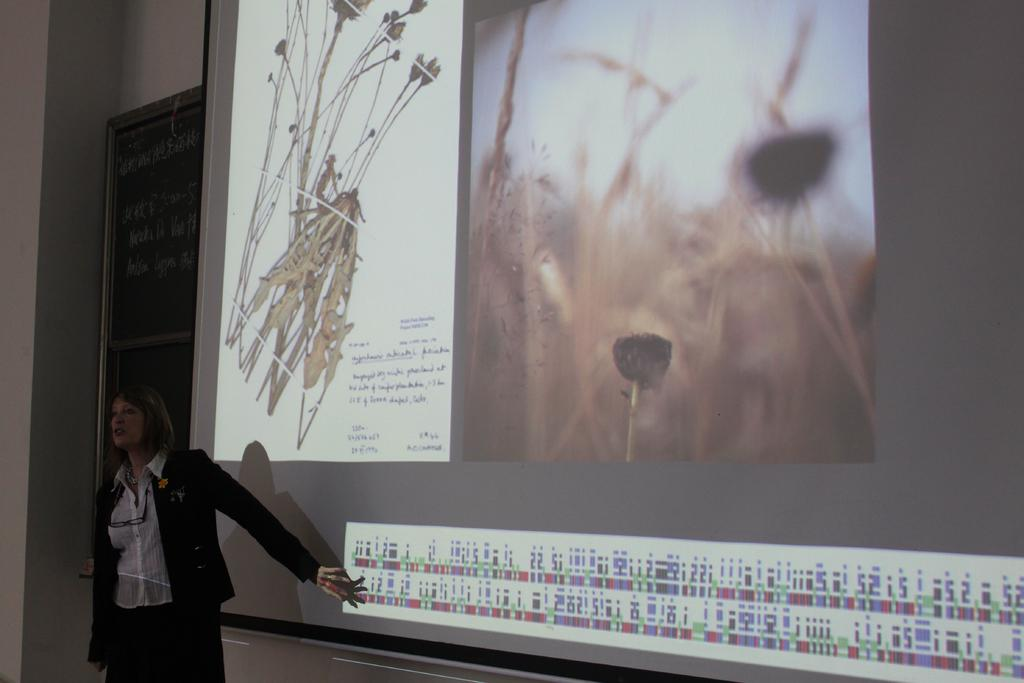What is the main subject of the image? There is a woman standing in the center of the image. Can you describe the background of the image? There is a screen behind the woman. What type of friction can be seen between the woman and the ice in the image? There is no ice present in the image, and therefore no friction between the woman and ice can be observed. 